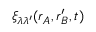<formula> <loc_0><loc_0><loc_500><loc_500>\xi _ { \lambda \lambda ^ { \prime } } ( r _ { A } , r _ { B } ^ { \prime } , t )</formula> 